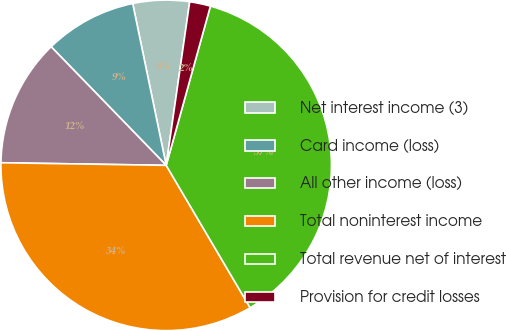Convert chart. <chart><loc_0><loc_0><loc_500><loc_500><pie_chart><fcel>Net interest income (3)<fcel>Card income (loss)<fcel>All other income (loss)<fcel>Total noninterest income<fcel>Total revenue net of interest<fcel>Provision for credit losses<nl><fcel>5.52%<fcel>9.01%<fcel>12.49%<fcel>33.73%<fcel>37.21%<fcel>2.04%<nl></chart> 